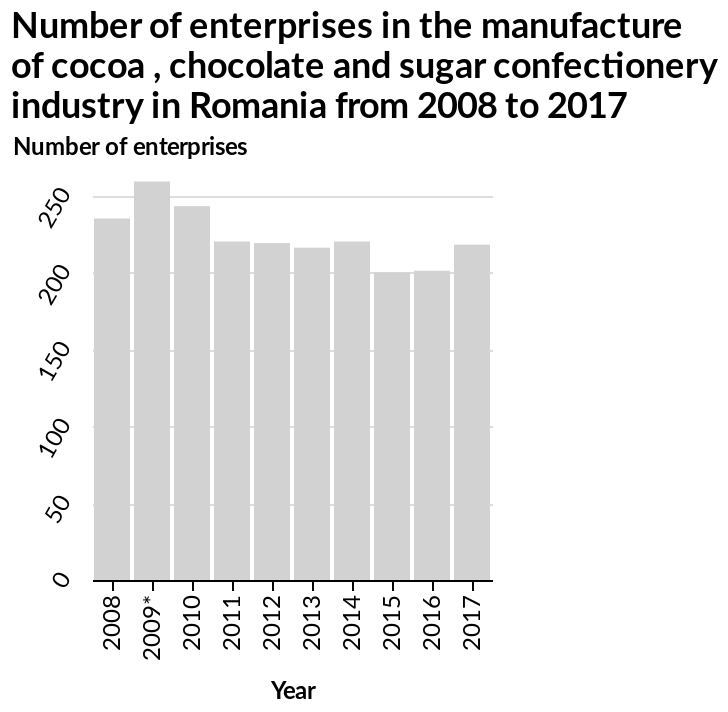<image>
In which year did the number of enterprises reach its peak? The number of enterprises reached its peak in 2009 with over 250 enterprises. What type of diagram is used to represent the data? A bar diagram is used to represent the data. 